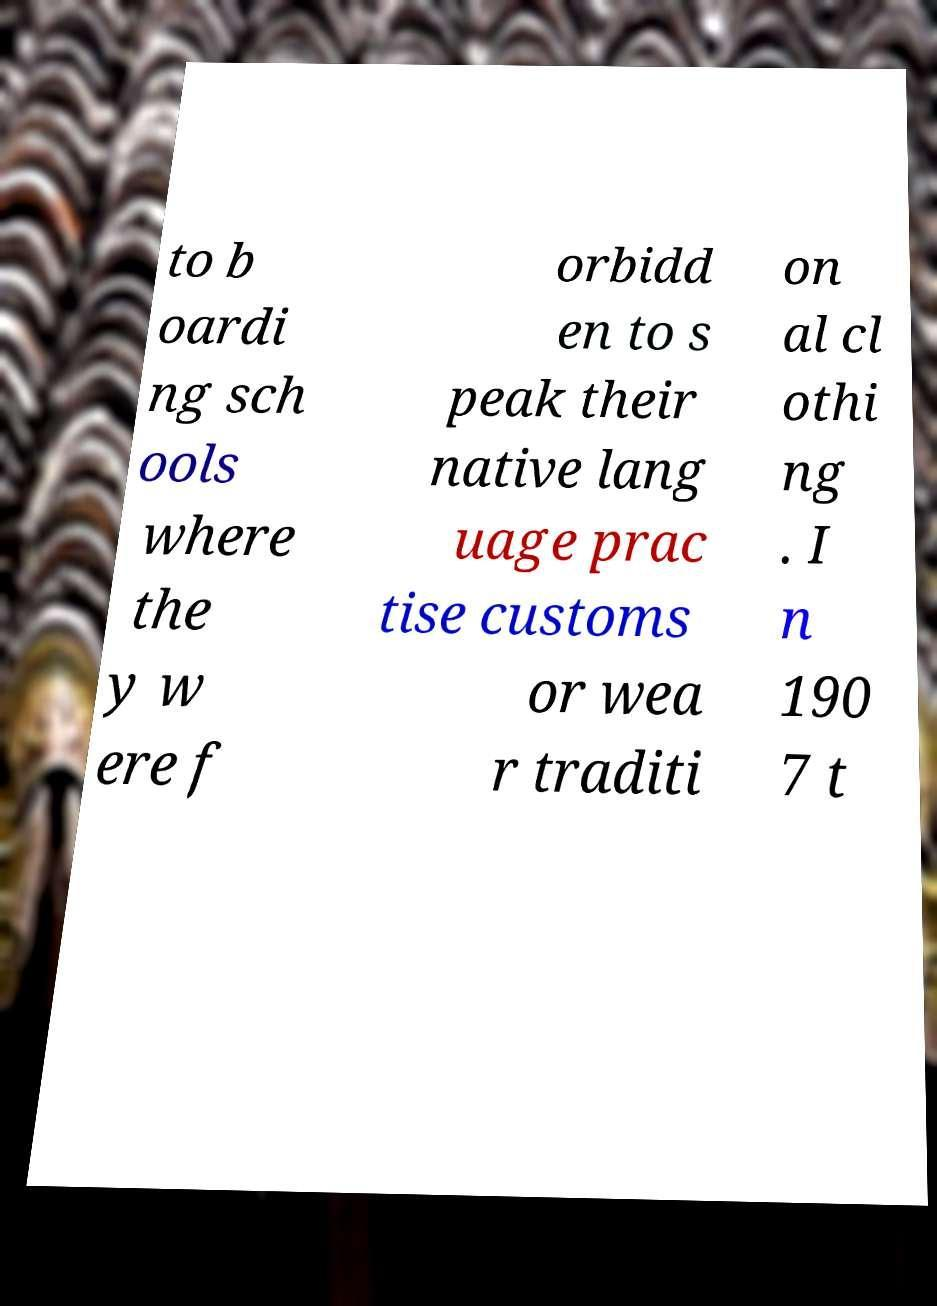Please identify and transcribe the text found in this image. to b oardi ng sch ools where the y w ere f orbidd en to s peak their native lang uage prac tise customs or wea r traditi on al cl othi ng . I n 190 7 t 